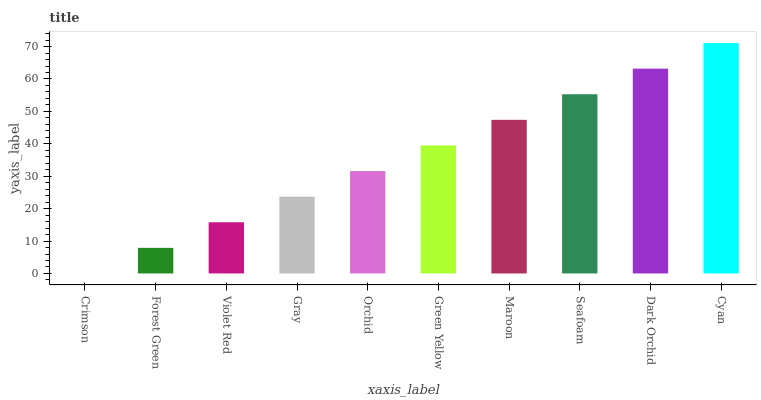Is Cyan the maximum?
Answer yes or no. Yes. Is Forest Green the minimum?
Answer yes or no. No. Is Forest Green the maximum?
Answer yes or no. No. Is Forest Green greater than Crimson?
Answer yes or no. Yes. Is Crimson less than Forest Green?
Answer yes or no. Yes. Is Crimson greater than Forest Green?
Answer yes or no. No. Is Forest Green less than Crimson?
Answer yes or no. No. Is Green Yellow the high median?
Answer yes or no. Yes. Is Orchid the low median?
Answer yes or no. Yes. Is Maroon the high median?
Answer yes or no. No. Is Dark Orchid the low median?
Answer yes or no. No. 